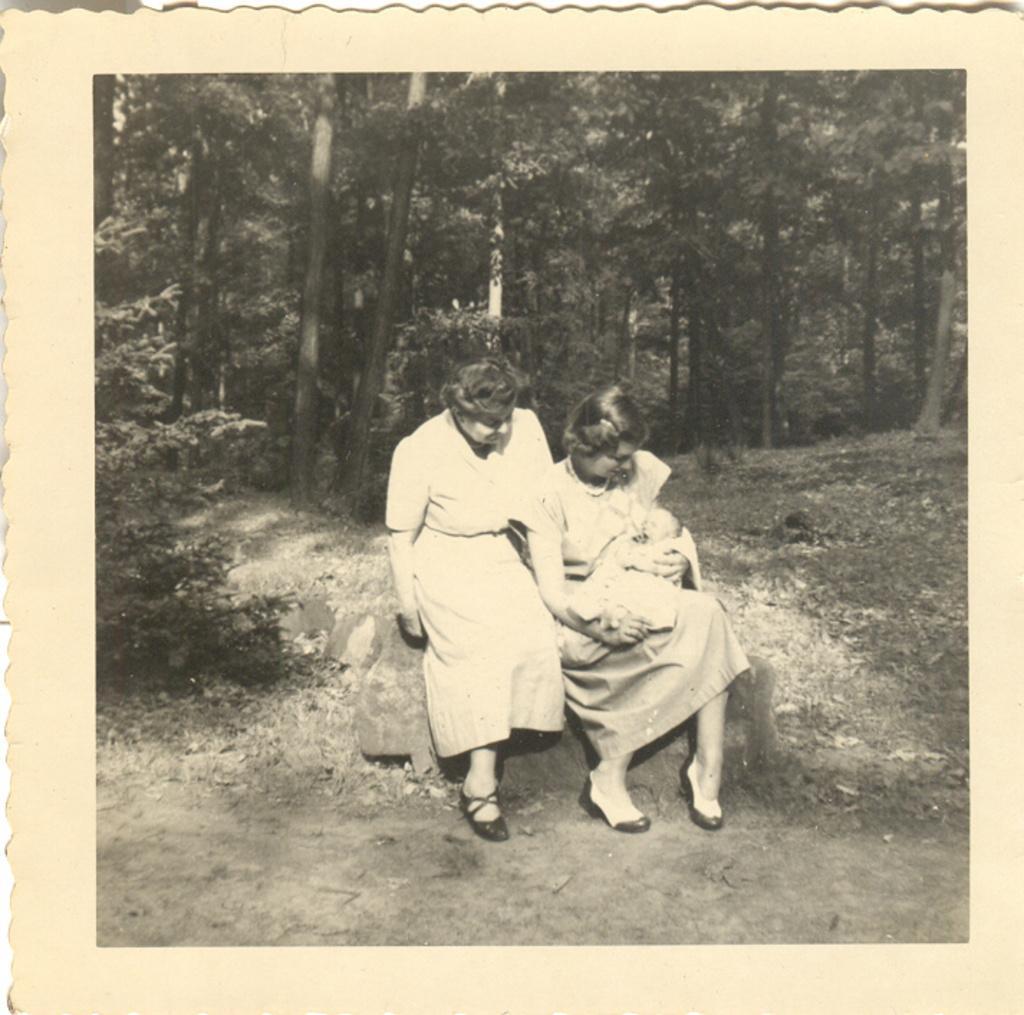Could you give a brief overview of what you see in this image? There is a photo of a picture. In this picture, there are two persons wearing clothes and sitting on the rock in front of trees. 